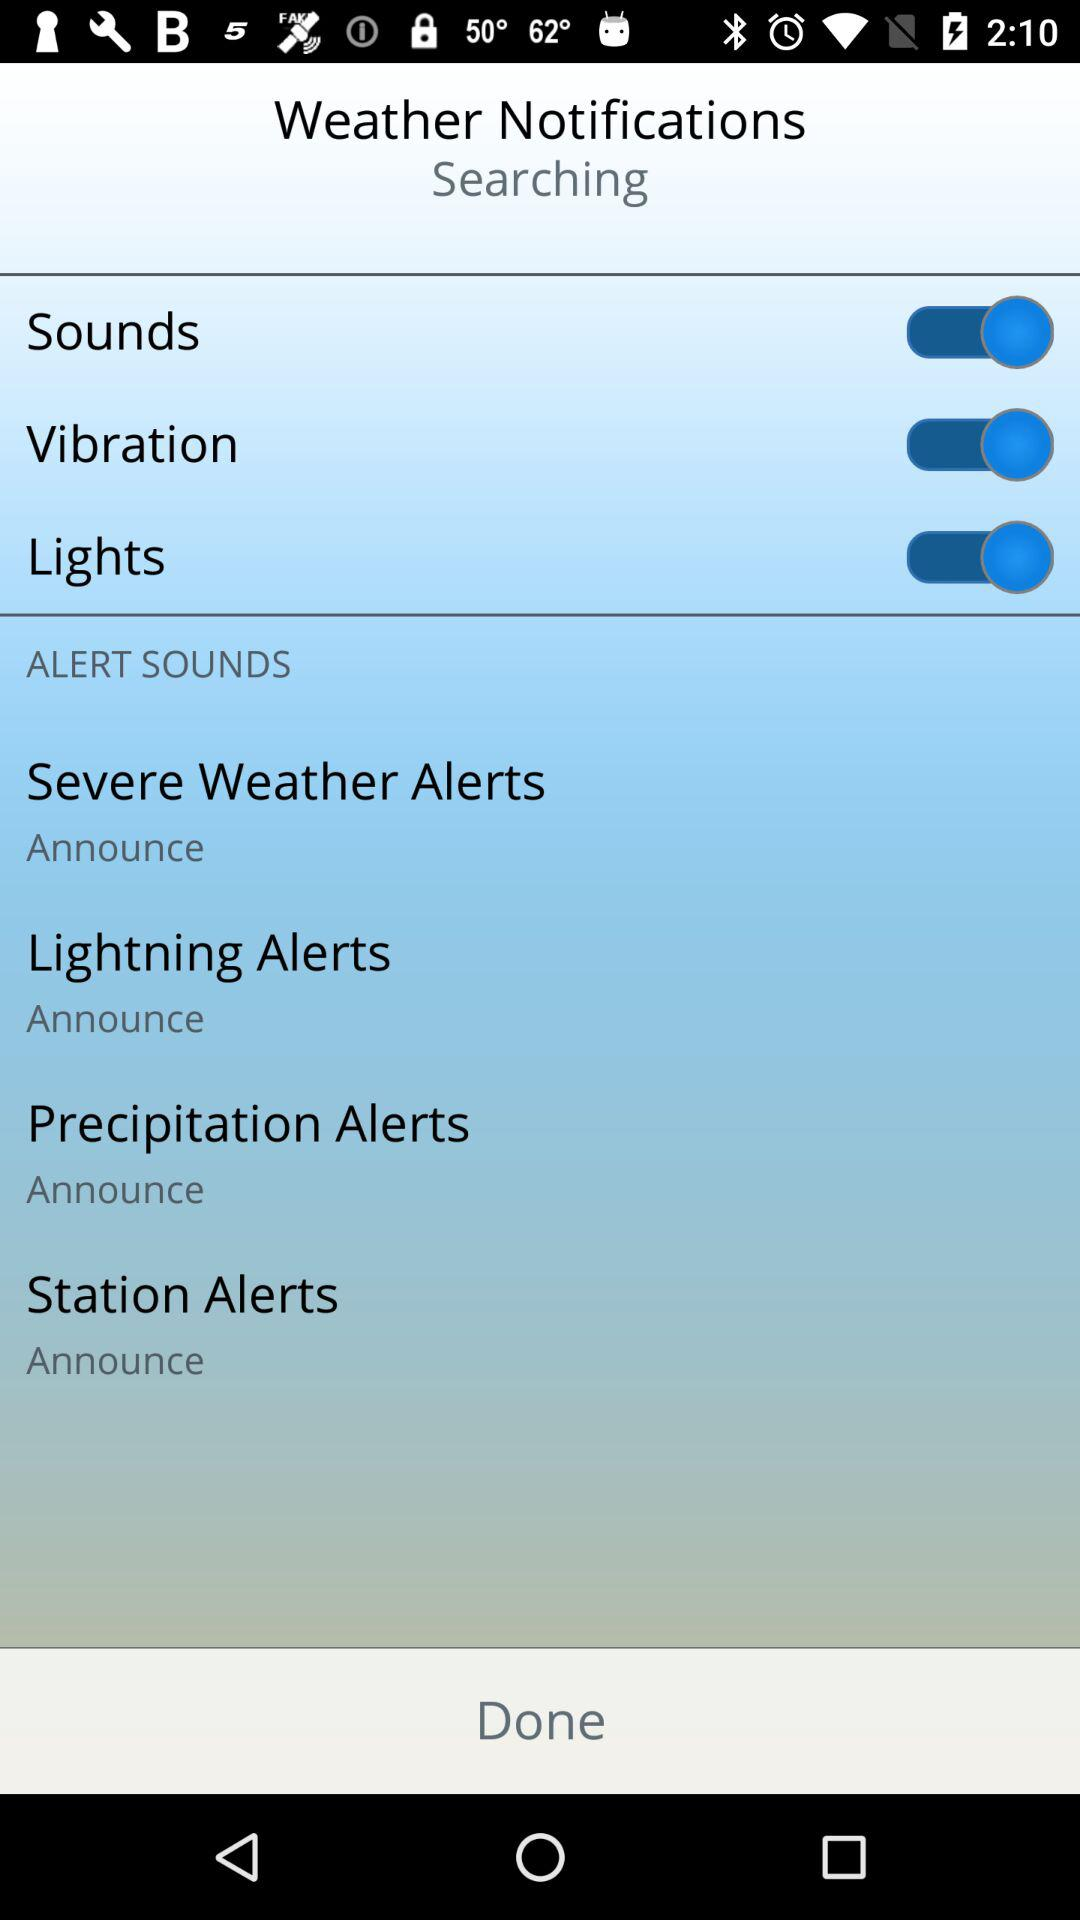What is the status of the "Vibration"? The status of the "Vibration" is "on". 